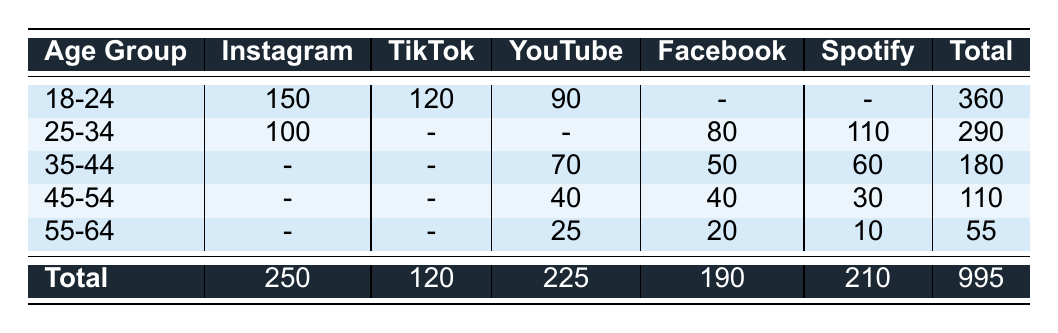What age group discovered jazz the most on Instagram? In the table, under the "Instagram" column, the age group "18-24" has the highest count of 150 for discovering jazz.
Answer: 18-24 How many people from the age group 35-44 discovered jazz on YouTube? Looking at the "YouTube" column for the "35-44" age group, we see that 70 people discovered jazz.
Answer: 70 Which social media platform was used the least by the 45-54 age group to discover jazz? The counts for the 45-54 age group across platforms are as follows: Facebook (40), YouTube (40), and Spotify (30). The lowest count is for Spotify with 30.
Answer: Spotify What is the total number of people from the age group 55-64 who discovered jazz across all platforms? For the age group 55-64, the counts are: Facebook (20), YouTube (25), and Spotify (10). Summing these values gives 20 + 25 + 10 = 55.
Answer: 55 Is it true that more people from the 25-34 age group discovered jazz on Spotify than on Facebook? For the 25-34 age group, 110 discovered jazz on Spotify and 80 on Facebook. Since 110 is greater than 80, the statement is true.
Answer: True What is the difference in the number of people discovering jazz on TikTok between the age groups 18-24 and 25-34? The age group 18-24 discovered jazz on TikTok with a count of 120, while the age group 25-34 did not discover jazz on TikTok (count is -). This gives a difference of 120 - 0 = 120.
Answer: 120 How many people in total discovered jazz across all platforms for the age group 25-34? For the age group 25-34, the counts are Instagram (100), Facebook (80), and Spotify (110). Adding these gives 100 + 80 + 110 = 290.
Answer: 290 How many total individuals discovered jazz via Facebook? From the table, the counts for Facebook are: 80 (age 25-34), 50 (age 35-44), 40 (age 45-54), and 20 (age 55-64). Summing these counts gives 80 + 50 + 40 + 20 = 190.
Answer: 190 Which age group has the lowest total number of jazz discoveries across all platforms? The sum for each age group is: 18-24: 360, 25-34: 290, 35-44: 180, 45-54: 110, 55-64: 55. The lowest total is 55 for the age group 55-64.
Answer: 55-64 